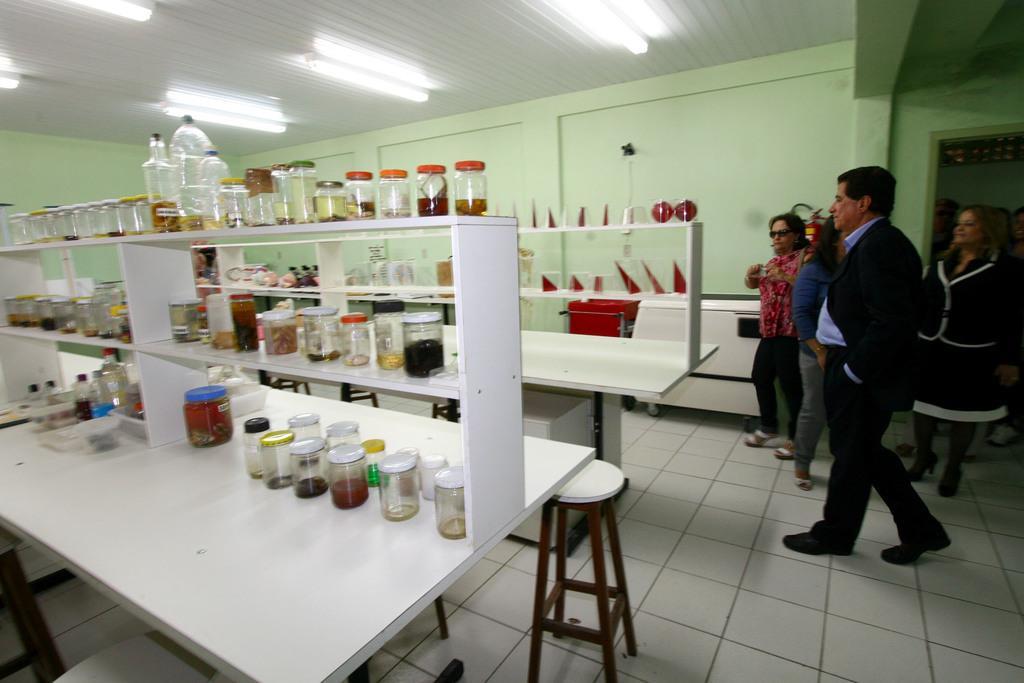How would you summarize this image in a sentence or two? In this image i can see some bottles on a wood rack,a chair at the right side there are three women and a man standing, at the back ground there is a wall,at the top there is a light. 